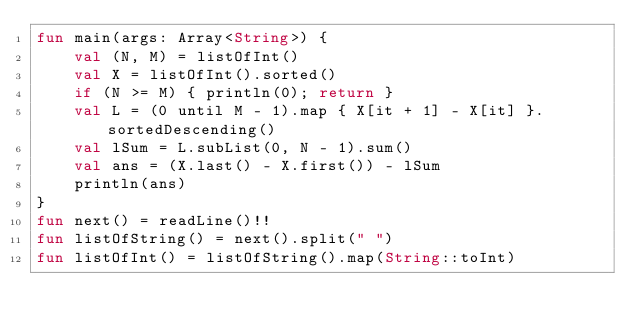<code> <loc_0><loc_0><loc_500><loc_500><_Kotlin_>fun main(args: Array<String>) {
    val (N, M) = listOfInt()
    val X = listOfInt().sorted()
    if (N >= M) { println(0); return }
    val L = (0 until M - 1).map { X[it + 1] - X[it] }.sortedDescending()
    val lSum = L.subList(0, N - 1).sum()
    val ans = (X.last() - X.first()) - lSum
    println(ans)
}
fun next() = readLine()!!
fun listOfString() = next().split(" ")
fun listOfInt() = listOfString().map(String::toInt)</code> 